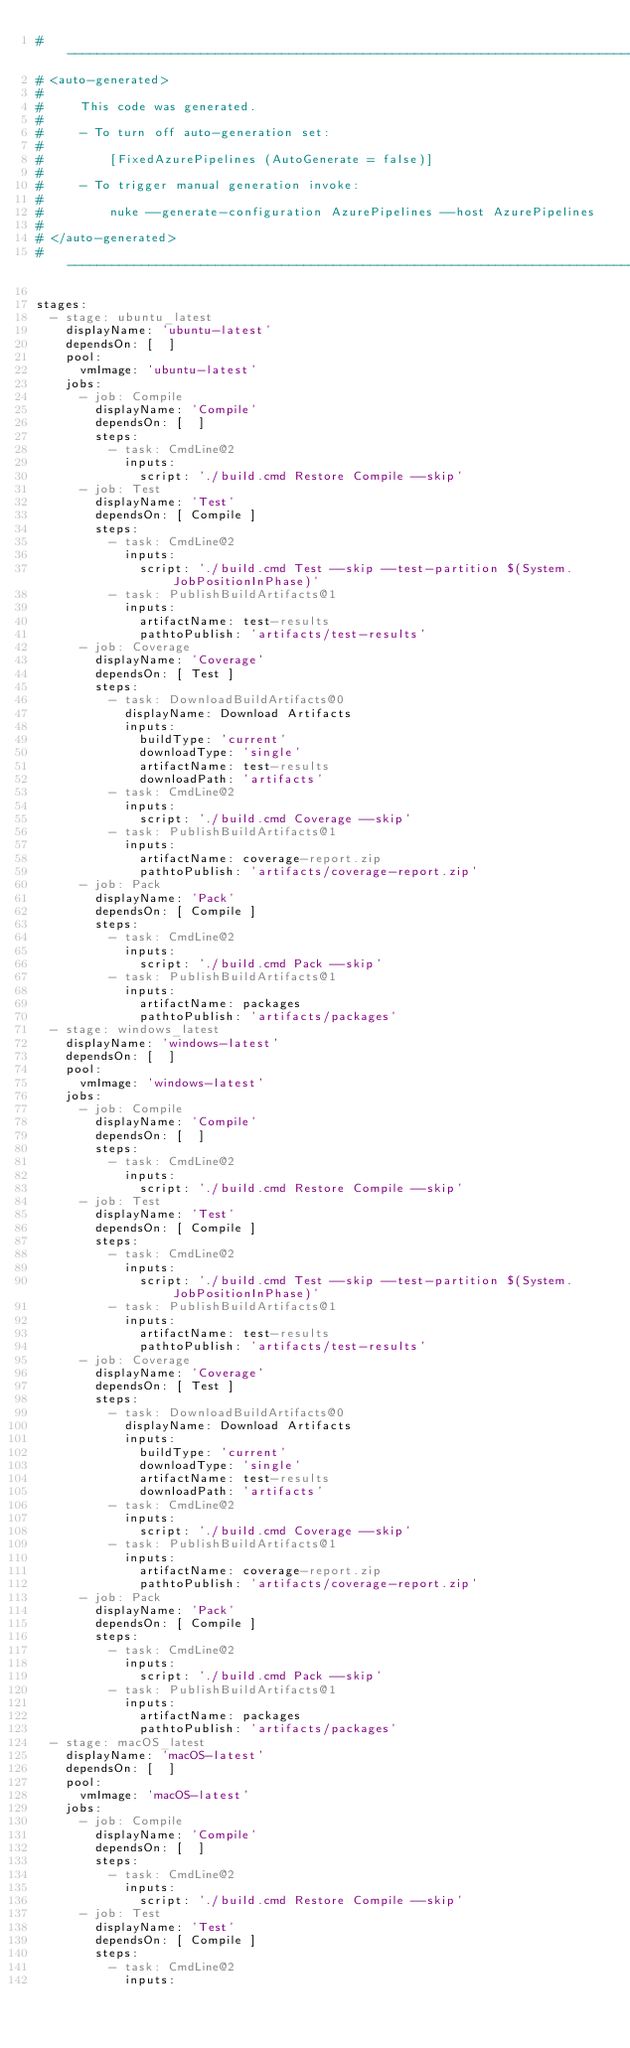Convert code to text. <code><loc_0><loc_0><loc_500><loc_500><_YAML_># ------------------------------------------------------------------------------
# <auto-generated>
#
#     This code was generated.
#
#     - To turn off auto-generation set:
#
#         [FixedAzurePipelines (AutoGenerate = false)]
#
#     - To trigger manual generation invoke:
#
#         nuke --generate-configuration AzurePipelines --host AzurePipelines
#
# </auto-generated>
# ------------------------------------------------------------------------------

stages:
  - stage: ubuntu_latest
    displayName: 'ubuntu-latest'
    dependsOn: [  ]
    pool:
      vmImage: 'ubuntu-latest'
    jobs:
      - job: Compile
        displayName: 'Compile'
        dependsOn: [  ]
        steps:
          - task: CmdLine@2
            inputs:
              script: './build.cmd Restore Compile --skip'
      - job: Test
        displayName: 'Test'
        dependsOn: [ Compile ]
        steps:
          - task: CmdLine@2
            inputs:
              script: './build.cmd Test --skip --test-partition $(System.JobPositionInPhase)'
          - task: PublishBuildArtifacts@1
            inputs:
              artifactName: test-results
              pathtoPublish: 'artifacts/test-results'
      - job: Coverage
        displayName: 'Coverage'
        dependsOn: [ Test ]
        steps:
          - task: DownloadBuildArtifacts@0
            displayName: Download Artifacts
            inputs:
              buildType: 'current'
              downloadType: 'single'
              artifactName: test-results
              downloadPath: 'artifacts'
          - task: CmdLine@2
            inputs:
              script: './build.cmd Coverage --skip'
          - task: PublishBuildArtifacts@1
            inputs:
              artifactName: coverage-report.zip
              pathtoPublish: 'artifacts/coverage-report.zip'
      - job: Pack
        displayName: 'Pack'
        dependsOn: [ Compile ]
        steps:
          - task: CmdLine@2
            inputs:
              script: './build.cmd Pack --skip'
          - task: PublishBuildArtifacts@1
            inputs:
              artifactName: packages
              pathtoPublish: 'artifacts/packages'
  - stage: windows_latest
    displayName: 'windows-latest'
    dependsOn: [  ]
    pool:
      vmImage: 'windows-latest'
    jobs:
      - job: Compile
        displayName: 'Compile'
        dependsOn: [  ]
        steps:
          - task: CmdLine@2
            inputs:
              script: './build.cmd Restore Compile --skip'
      - job: Test
        displayName: 'Test'
        dependsOn: [ Compile ]
        steps:
          - task: CmdLine@2
            inputs:
              script: './build.cmd Test --skip --test-partition $(System.JobPositionInPhase)'
          - task: PublishBuildArtifacts@1
            inputs:
              artifactName: test-results
              pathtoPublish: 'artifacts/test-results'
      - job: Coverage
        displayName: 'Coverage'
        dependsOn: [ Test ]
        steps:
          - task: DownloadBuildArtifacts@0
            displayName: Download Artifacts
            inputs:
              buildType: 'current'
              downloadType: 'single'
              artifactName: test-results
              downloadPath: 'artifacts'
          - task: CmdLine@2
            inputs:
              script: './build.cmd Coverage --skip'
          - task: PublishBuildArtifacts@1
            inputs:
              artifactName: coverage-report.zip
              pathtoPublish: 'artifacts/coverage-report.zip'
      - job: Pack
        displayName: 'Pack'
        dependsOn: [ Compile ]
        steps:
          - task: CmdLine@2
            inputs:
              script: './build.cmd Pack --skip'
          - task: PublishBuildArtifacts@1
            inputs:
              artifactName: packages
              pathtoPublish: 'artifacts/packages'
  - stage: macOS_latest
    displayName: 'macOS-latest'
    dependsOn: [  ]
    pool:
      vmImage: 'macOS-latest'
    jobs:
      - job: Compile
        displayName: 'Compile'
        dependsOn: [  ]
        steps:
          - task: CmdLine@2
            inputs:
              script: './build.cmd Restore Compile --skip'
      - job: Test
        displayName: 'Test'
        dependsOn: [ Compile ]
        steps:
          - task: CmdLine@2
            inputs:</code> 